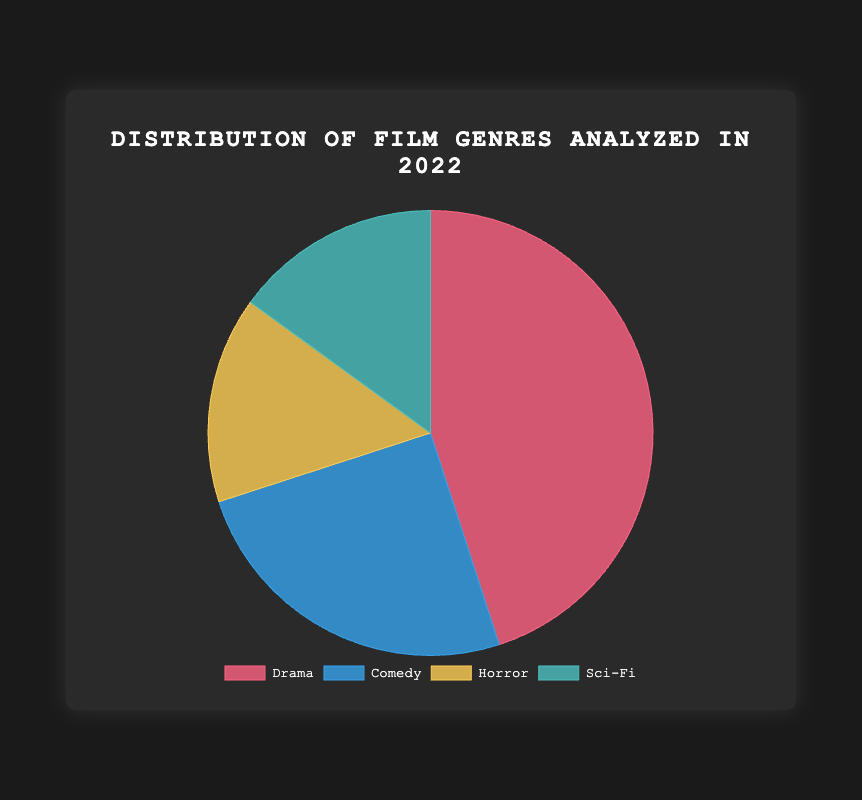What percentage of the total genres analyzed does Comedy represent? To find the percentage that Comedy represents, divide the number of Comedy films by the total number of films and then multiply by 100: (25 / (45 + 25 + 15 + 15)) * 100%.
Answer: 25% How many more Drama films were analyzed compared to Horror films? Subtract the number of Horror films analyzed from the number of Drama films: 45 - 15.
Answer: 30 Which genre has the smallest representation, and what percentage does it constitute? Both Horror and Sci-Fi have the smallest representation with 15 films each. Their percentage is calculated as follows: (15 / (45 + 25 + 15 + 15)) * 100%.
Answer: Sci-Fi and Horror, 15% What is the combined percentage of Drama and Comedy films analyzed? Add the number of Drama and Comedy films, then divide by the total number of films and multiply by 100: ((45 + 25) / (45 + 25 + 15 + 15)) * 100%.
Answer: 70% If the representation of Sci-Fi films doubled, what would be its new percentage of the total? If Sci-Fi doubles, it will have 30 films. Calculate the new total: 45 + 25 + 15 + 30 = 115, then find the new percentage: (30 / 115) * 100%.
Answer: 26.1% Between Comedy and Horror, which genre has the higher representation and by how much? Subtract the number of Horror films from Comedy films: 25 - 15.
Answer: Comedy, by 10 What are the visual colors associated with the Drama and Sci-Fi genres in the pie chart? Drama is associated with the color that appears red, and Sci-Fi with a teal-like green color.
Answer: Red for Drama, Teal for Sci-Fi 